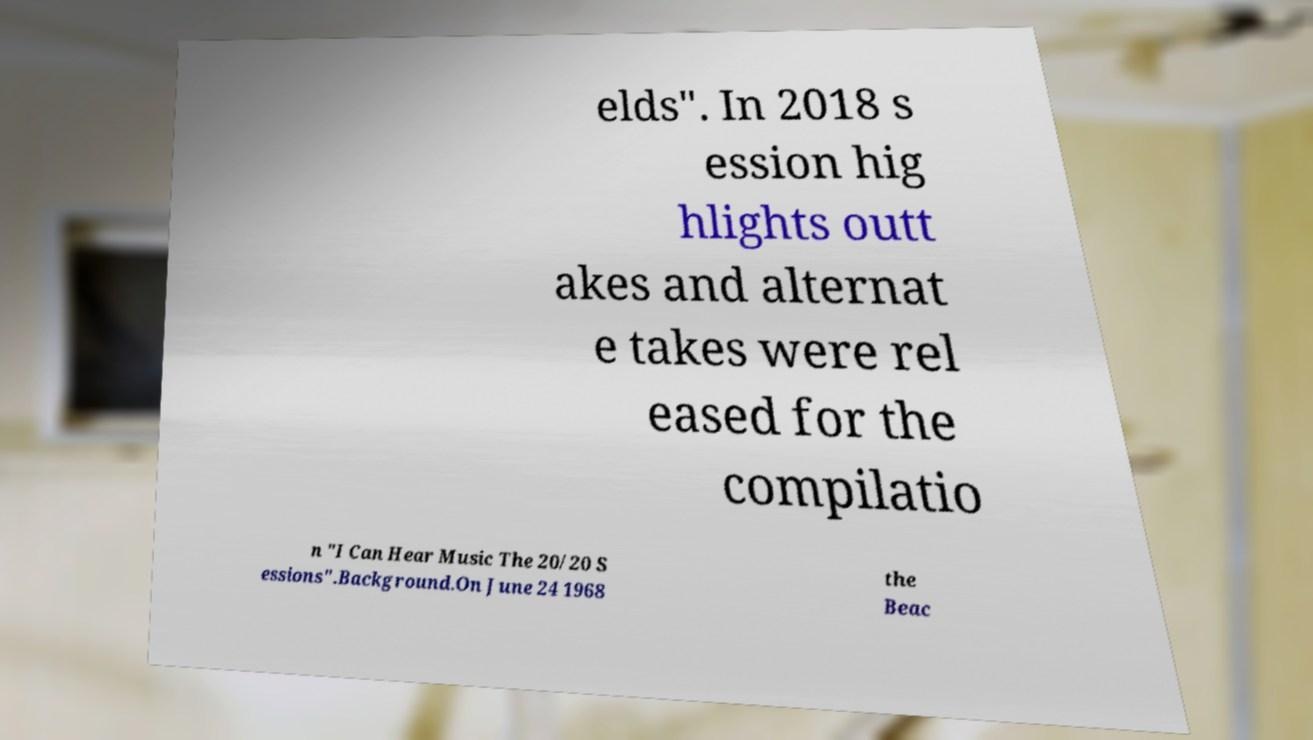Can you read and provide the text displayed in the image?This photo seems to have some interesting text. Can you extract and type it out for me? elds". In 2018 s ession hig hlights outt akes and alternat e takes were rel eased for the compilatio n "I Can Hear Music The 20/20 S essions".Background.On June 24 1968 the Beac 